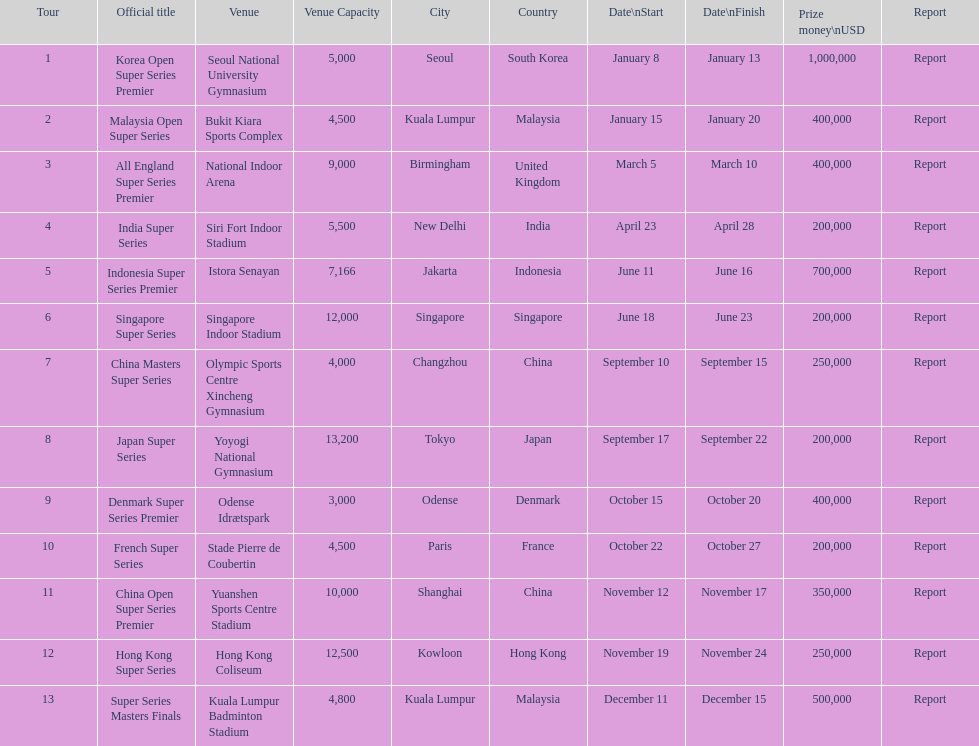How many occur in the last six months of the year? 7. 